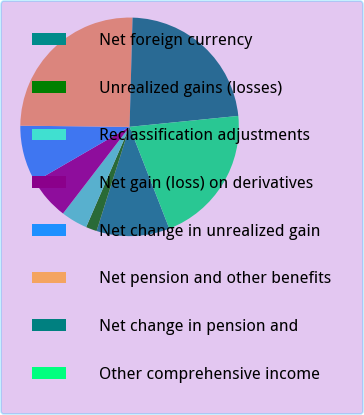Convert chart to OTSL. <chart><loc_0><loc_0><loc_500><loc_500><pie_chart><fcel>Net foreign currency<fcel>Unrealized gains (losses)<fcel>Reclassification adjustments<fcel>Net gain (loss) on derivatives<fcel>Net change in unrealized gain<fcel>Net pension and other benefits<fcel>Net change in pension and<fcel>Other comprehensive income<nl><fcel>10.81%<fcel>1.62%<fcel>3.92%<fcel>6.22%<fcel>8.52%<fcel>25.27%<fcel>22.97%<fcel>20.67%<nl></chart> 